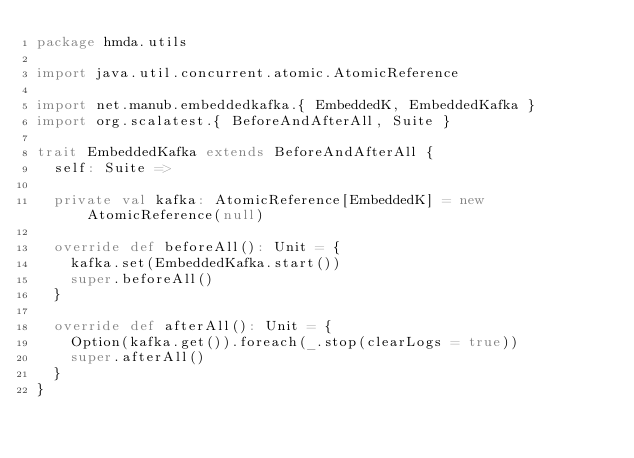Convert code to text. <code><loc_0><loc_0><loc_500><loc_500><_Scala_>package hmda.utils

import java.util.concurrent.atomic.AtomicReference

import net.manub.embeddedkafka.{ EmbeddedK, EmbeddedKafka }
import org.scalatest.{ BeforeAndAfterAll, Suite }

trait EmbeddedKafka extends BeforeAndAfterAll {
  self: Suite =>

  private val kafka: AtomicReference[EmbeddedK] = new AtomicReference(null)

  override def beforeAll(): Unit = {
    kafka.set(EmbeddedKafka.start())
    super.beforeAll()
  }

  override def afterAll(): Unit = {
    Option(kafka.get()).foreach(_.stop(clearLogs = true))
    super.afterAll()
  }
}</code> 